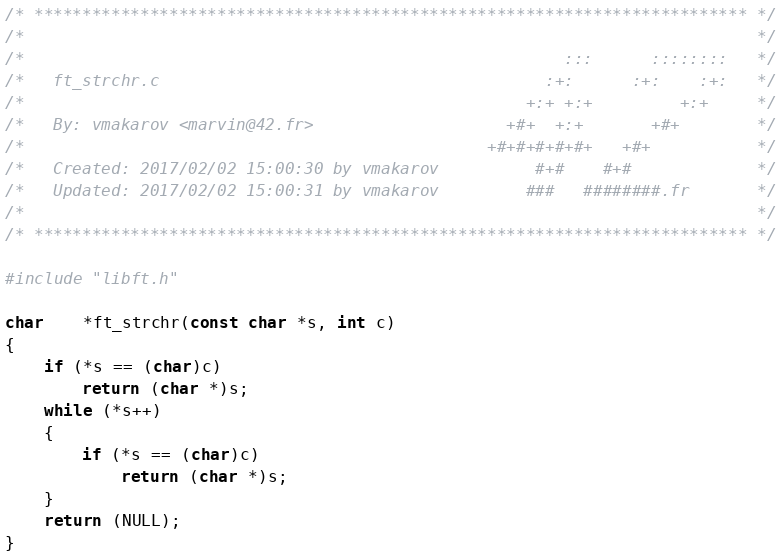<code> <loc_0><loc_0><loc_500><loc_500><_C_>/* ************************************************************************** */
/*                                                                            */
/*                                                        :::      ::::::::   */
/*   ft_strchr.c                                        :+:      :+:    :+:   */
/*                                                    +:+ +:+         +:+     */
/*   By: vmakarov <marvin@42.fr>                    +#+  +:+       +#+        */
/*                                                +#+#+#+#+#+   +#+           */
/*   Created: 2017/02/02 15:00:30 by vmakarov          #+#    #+#             */
/*   Updated: 2017/02/02 15:00:31 by vmakarov         ###   ########.fr       */
/*                                                                            */
/* ************************************************************************** */

#include "libft.h"

char	*ft_strchr(const char *s, int c)
{
	if (*s == (char)c)
		return (char *)s;
	while (*s++)
	{
		if (*s == (char)c)
			return (char *)s;
	}
	return (NULL);
}
</code> 